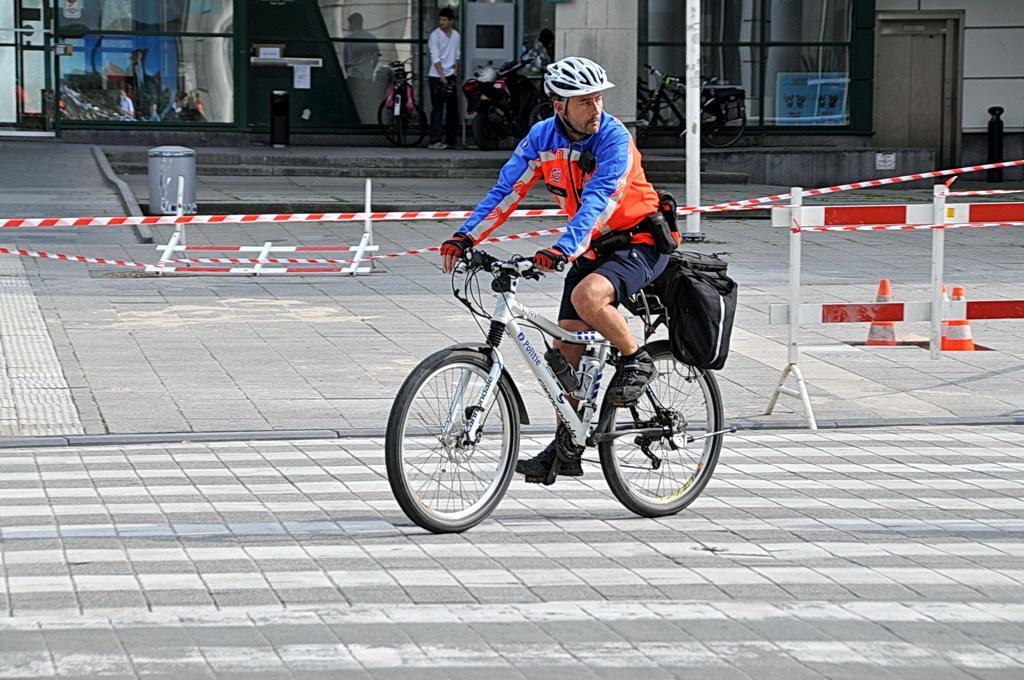How would you summarize this image in a sentence or two? In this picture we can see a man is riding a bicycle on the road. Behind the man there are traffic cones, barricade, bicycles, a person, a motorcycle and some objects. Behind the bicycles, it looks like a building. 